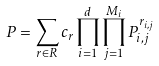<formula> <loc_0><loc_0><loc_500><loc_500>P = \sum _ { r \in R } c _ { r } \prod _ { i = 1 } ^ { d } \prod _ { j = 1 } ^ { M _ { i } } P _ { i , j } ^ { r _ { i , j } }</formula> 